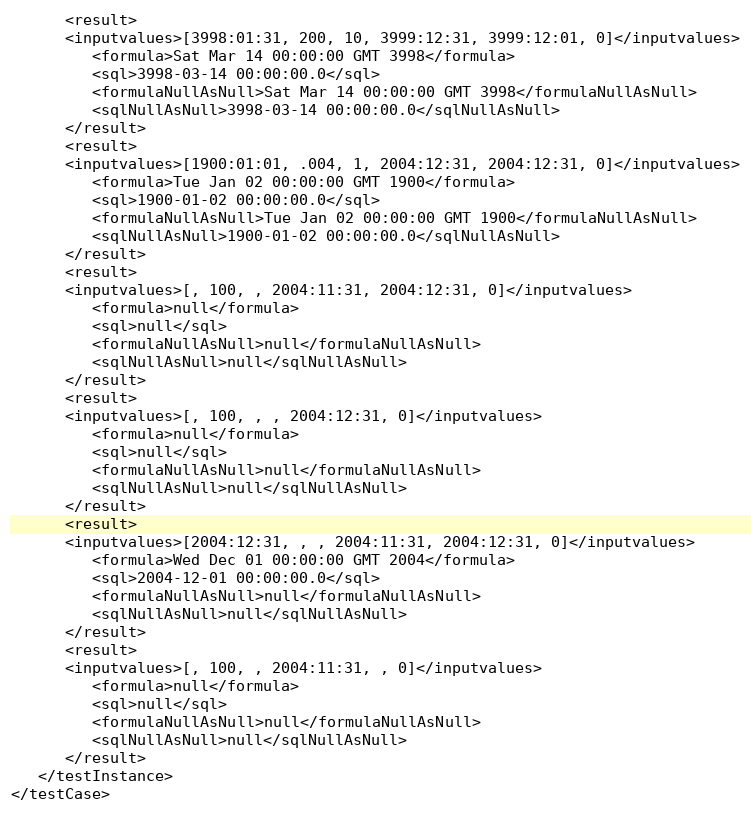<code> <loc_0><loc_0><loc_500><loc_500><_XML_>      <result>
      <inputvalues>[3998:01:31, 200, 10, 3999:12:31, 3999:12:01, 0]</inputvalues>
         <formula>Sat Mar 14 00:00:00 GMT 3998</formula>
         <sql>3998-03-14 00:00:00.0</sql>
         <formulaNullAsNull>Sat Mar 14 00:00:00 GMT 3998</formulaNullAsNull>
         <sqlNullAsNull>3998-03-14 00:00:00.0</sqlNullAsNull>
      </result>
      <result>
      <inputvalues>[1900:01:01, .004, 1, 2004:12:31, 2004:12:31, 0]</inputvalues>
         <formula>Tue Jan 02 00:00:00 GMT 1900</formula>
         <sql>1900-01-02 00:00:00.0</sql>
         <formulaNullAsNull>Tue Jan 02 00:00:00 GMT 1900</formulaNullAsNull>
         <sqlNullAsNull>1900-01-02 00:00:00.0</sqlNullAsNull>
      </result>
      <result>
      <inputvalues>[, 100, , 2004:11:31, 2004:12:31, 0]</inputvalues>
         <formula>null</formula>
         <sql>null</sql>
         <formulaNullAsNull>null</formulaNullAsNull>
         <sqlNullAsNull>null</sqlNullAsNull>
      </result>
      <result>
      <inputvalues>[, 100, , , 2004:12:31, 0]</inputvalues>
         <formula>null</formula>
         <sql>null</sql>
         <formulaNullAsNull>null</formulaNullAsNull>
         <sqlNullAsNull>null</sqlNullAsNull>
      </result>
      <result>
      <inputvalues>[2004:12:31, , , 2004:11:31, 2004:12:31, 0]</inputvalues>
         <formula>Wed Dec 01 00:00:00 GMT 2004</formula>
         <sql>2004-12-01 00:00:00.0</sql>
         <formulaNullAsNull>null</formulaNullAsNull>
         <sqlNullAsNull>null</sqlNullAsNull>
      </result>
      <result>
      <inputvalues>[, 100, , 2004:11:31, , 0]</inputvalues>
         <formula>null</formula>
         <sql>null</sql>
         <formulaNullAsNull>null</formulaNullAsNull>
         <sqlNullAsNull>null</sqlNullAsNull>
      </result>
   </testInstance>
</testCase>
</code> 